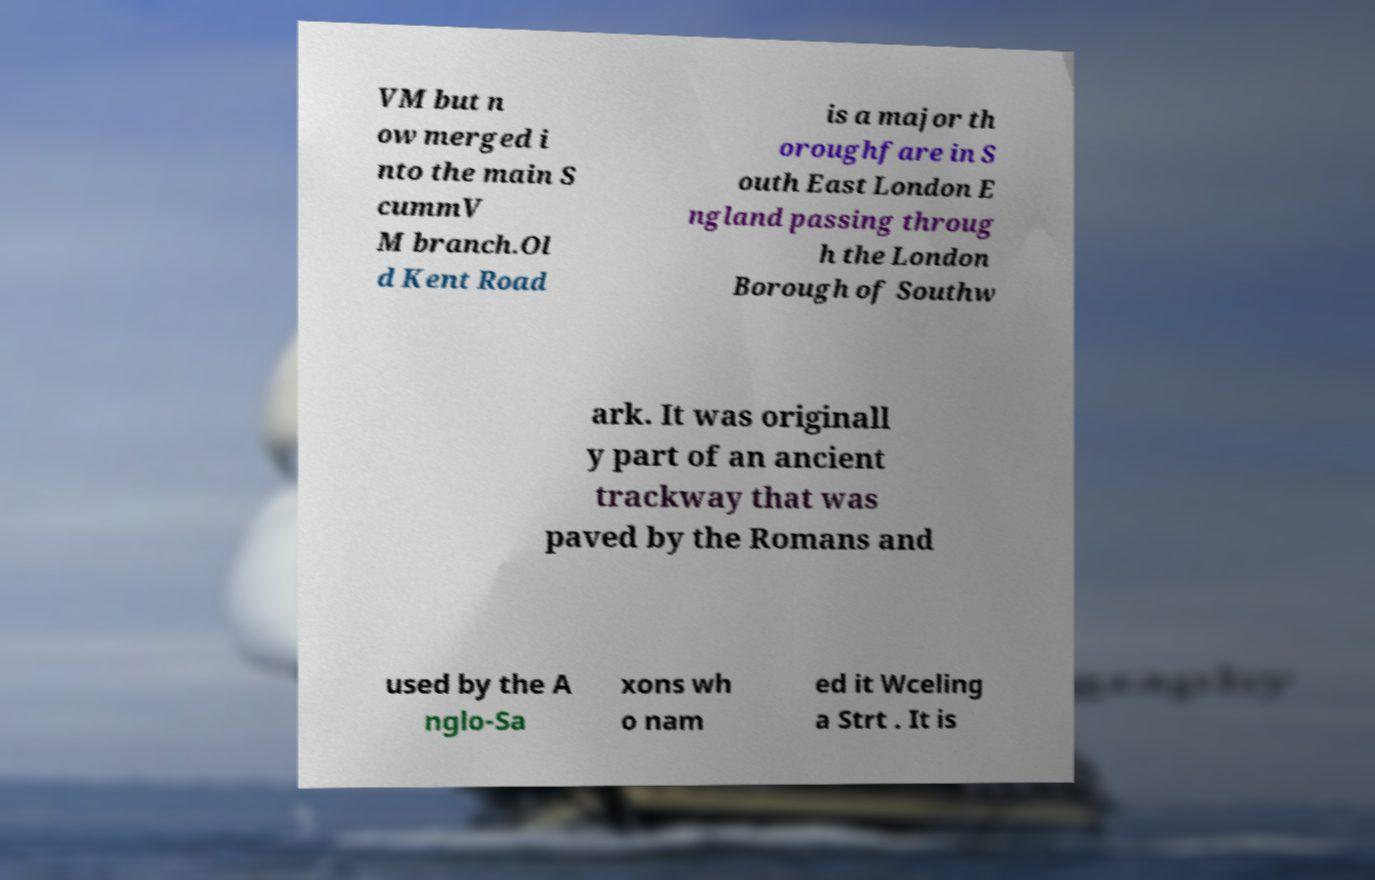Please identify and transcribe the text found in this image. VM but n ow merged i nto the main S cummV M branch.Ol d Kent Road is a major th oroughfare in S outh East London E ngland passing throug h the London Borough of Southw ark. It was originall y part of an ancient trackway that was paved by the Romans and used by the A nglo-Sa xons wh o nam ed it Wceling a Strt . It is 